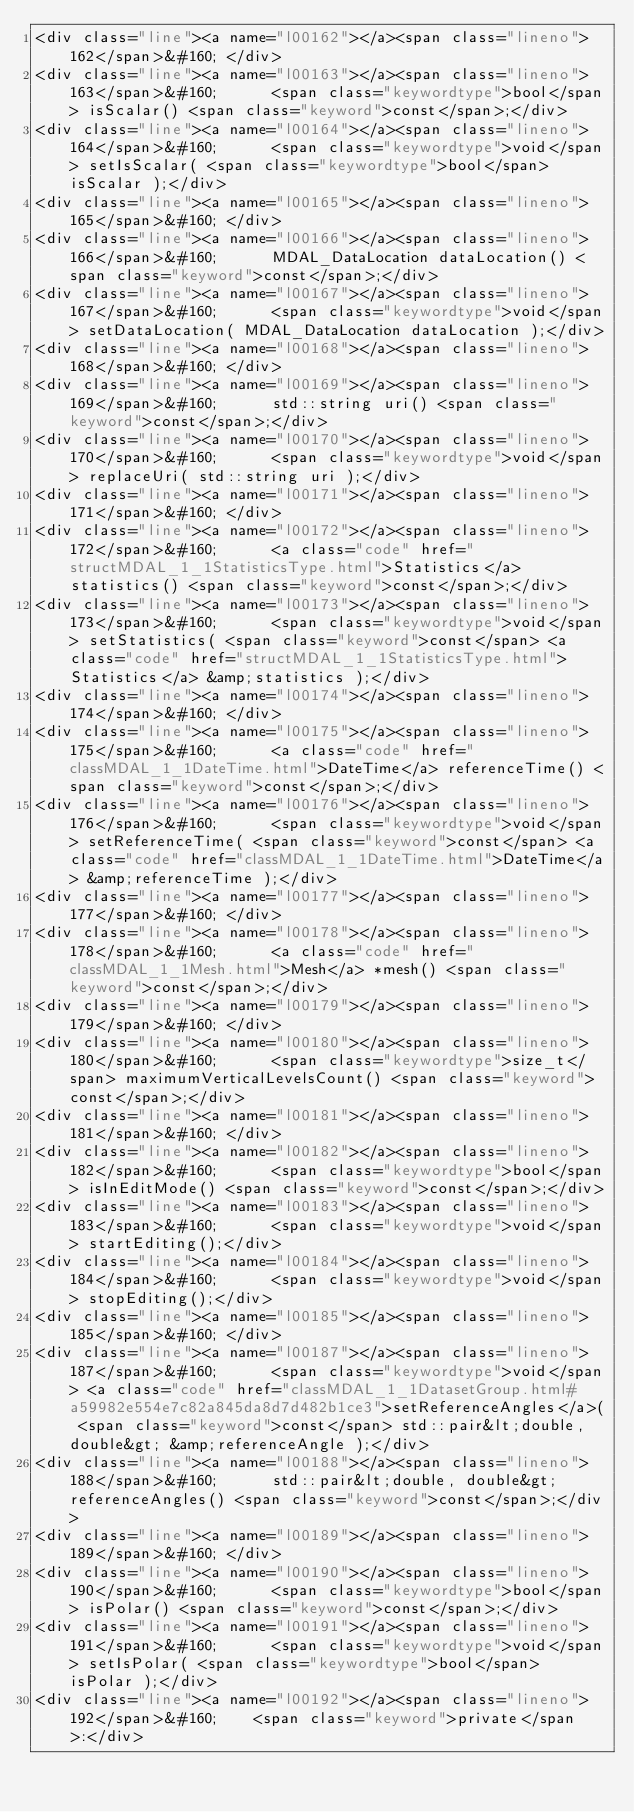<code> <loc_0><loc_0><loc_500><loc_500><_HTML_><div class="line"><a name="l00162"></a><span class="lineno">  162</span>&#160; </div>
<div class="line"><a name="l00163"></a><span class="lineno">  163</span>&#160;      <span class="keywordtype">bool</span> isScalar() <span class="keyword">const</span>;</div>
<div class="line"><a name="l00164"></a><span class="lineno">  164</span>&#160;      <span class="keywordtype">void</span> setIsScalar( <span class="keywordtype">bool</span> isScalar );</div>
<div class="line"><a name="l00165"></a><span class="lineno">  165</span>&#160; </div>
<div class="line"><a name="l00166"></a><span class="lineno">  166</span>&#160;      MDAL_DataLocation dataLocation() <span class="keyword">const</span>;</div>
<div class="line"><a name="l00167"></a><span class="lineno">  167</span>&#160;      <span class="keywordtype">void</span> setDataLocation( MDAL_DataLocation dataLocation );</div>
<div class="line"><a name="l00168"></a><span class="lineno">  168</span>&#160; </div>
<div class="line"><a name="l00169"></a><span class="lineno">  169</span>&#160;      std::string uri() <span class="keyword">const</span>;</div>
<div class="line"><a name="l00170"></a><span class="lineno">  170</span>&#160;      <span class="keywordtype">void</span> replaceUri( std::string uri );</div>
<div class="line"><a name="l00171"></a><span class="lineno">  171</span>&#160; </div>
<div class="line"><a name="l00172"></a><span class="lineno">  172</span>&#160;      <a class="code" href="structMDAL_1_1StatisticsType.html">Statistics</a> statistics() <span class="keyword">const</span>;</div>
<div class="line"><a name="l00173"></a><span class="lineno">  173</span>&#160;      <span class="keywordtype">void</span> setStatistics( <span class="keyword">const</span> <a class="code" href="structMDAL_1_1StatisticsType.html">Statistics</a> &amp;statistics );</div>
<div class="line"><a name="l00174"></a><span class="lineno">  174</span>&#160; </div>
<div class="line"><a name="l00175"></a><span class="lineno">  175</span>&#160;      <a class="code" href="classMDAL_1_1DateTime.html">DateTime</a> referenceTime() <span class="keyword">const</span>;</div>
<div class="line"><a name="l00176"></a><span class="lineno">  176</span>&#160;      <span class="keywordtype">void</span> setReferenceTime( <span class="keyword">const</span> <a class="code" href="classMDAL_1_1DateTime.html">DateTime</a> &amp;referenceTime );</div>
<div class="line"><a name="l00177"></a><span class="lineno">  177</span>&#160; </div>
<div class="line"><a name="l00178"></a><span class="lineno">  178</span>&#160;      <a class="code" href="classMDAL_1_1Mesh.html">Mesh</a> *mesh() <span class="keyword">const</span>;</div>
<div class="line"><a name="l00179"></a><span class="lineno">  179</span>&#160; </div>
<div class="line"><a name="l00180"></a><span class="lineno">  180</span>&#160;      <span class="keywordtype">size_t</span> maximumVerticalLevelsCount() <span class="keyword">const</span>;</div>
<div class="line"><a name="l00181"></a><span class="lineno">  181</span>&#160; </div>
<div class="line"><a name="l00182"></a><span class="lineno">  182</span>&#160;      <span class="keywordtype">bool</span> isInEditMode() <span class="keyword">const</span>;</div>
<div class="line"><a name="l00183"></a><span class="lineno">  183</span>&#160;      <span class="keywordtype">void</span> startEditing();</div>
<div class="line"><a name="l00184"></a><span class="lineno">  184</span>&#160;      <span class="keywordtype">void</span> stopEditing();</div>
<div class="line"><a name="l00185"></a><span class="lineno">  185</span>&#160; </div>
<div class="line"><a name="l00187"></a><span class="lineno">  187</span>&#160;      <span class="keywordtype">void</span> <a class="code" href="classMDAL_1_1DatasetGroup.html#a59982e554e7c82a845da8d7d482b1ce3">setReferenceAngles</a>( <span class="keyword">const</span> std::pair&lt;double, double&gt; &amp;referenceAngle );</div>
<div class="line"><a name="l00188"></a><span class="lineno">  188</span>&#160;      std::pair&lt;double, double&gt; referenceAngles() <span class="keyword">const</span>;</div>
<div class="line"><a name="l00189"></a><span class="lineno">  189</span>&#160; </div>
<div class="line"><a name="l00190"></a><span class="lineno">  190</span>&#160;      <span class="keywordtype">bool</span> isPolar() <span class="keyword">const</span>;</div>
<div class="line"><a name="l00191"></a><span class="lineno">  191</span>&#160;      <span class="keywordtype">void</span> setIsPolar( <span class="keywordtype">bool</span> isPolar );</div>
<div class="line"><a name="l00192"></a><span class="lineno">  192</span>&#160;    <span class="keyword">private</span>:</div></code> 